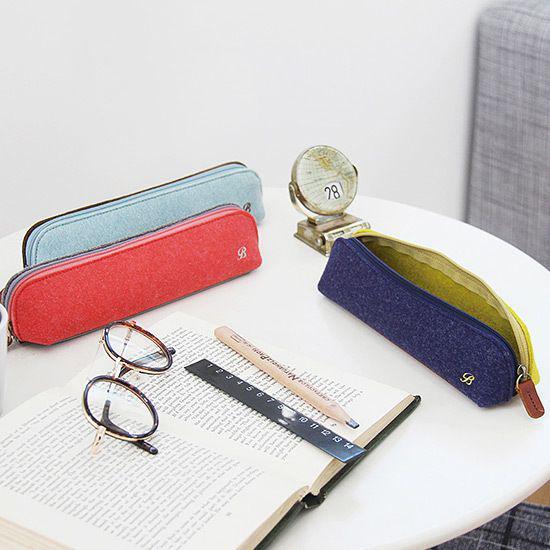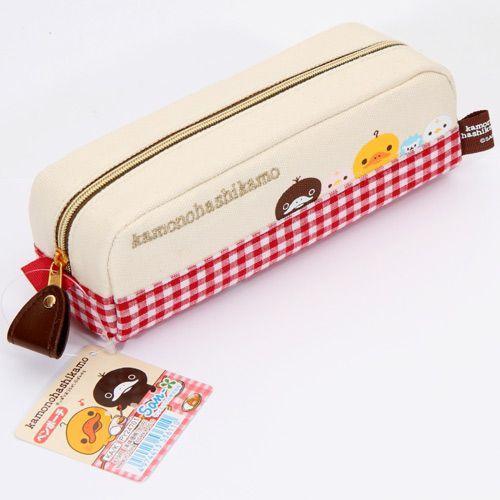The first image is the image on the left, the second image is the image on the right. Analyze the images presented: Is the assertion "One of the images features someone holding a pencil case." valid? Answer yes or no. No. The first image is the image on the left, the second image is the image on the right. Evaluate the accuracy of this statement regarding the images: "The left image shows a pair of hands holding a zipper case featuring light-blue color and its contents.". Is it true? Answer yes or no. No. 